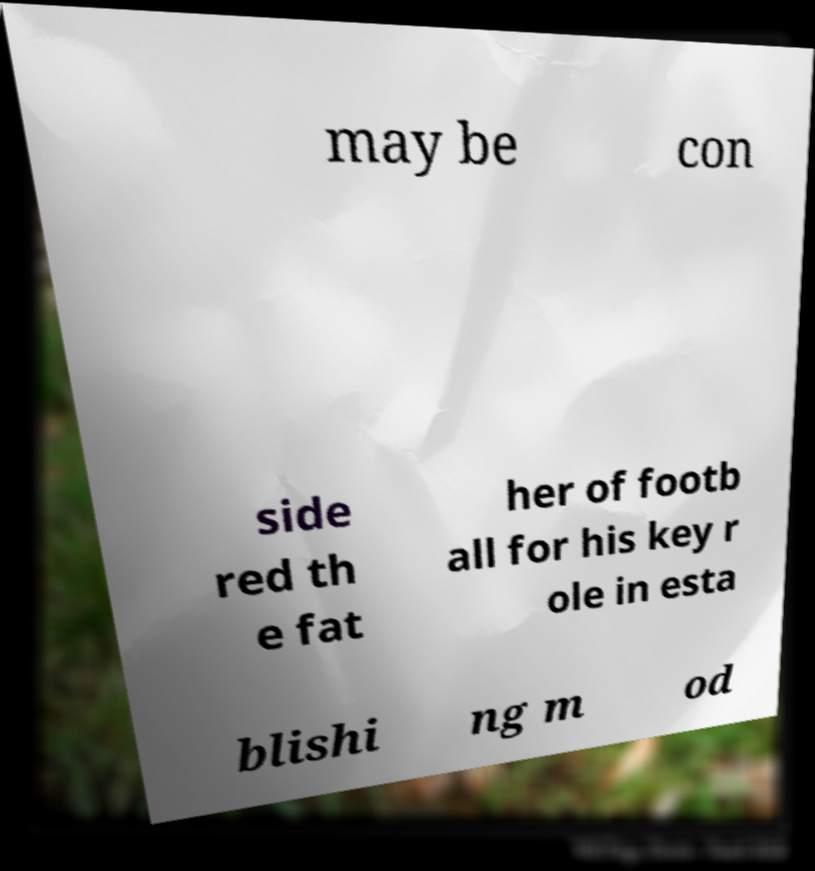Could you assist in decoding the text presented in this image and type it out clearly? may be con side red th e fat her of footb all for his key r ole in esta blishi ng m od 